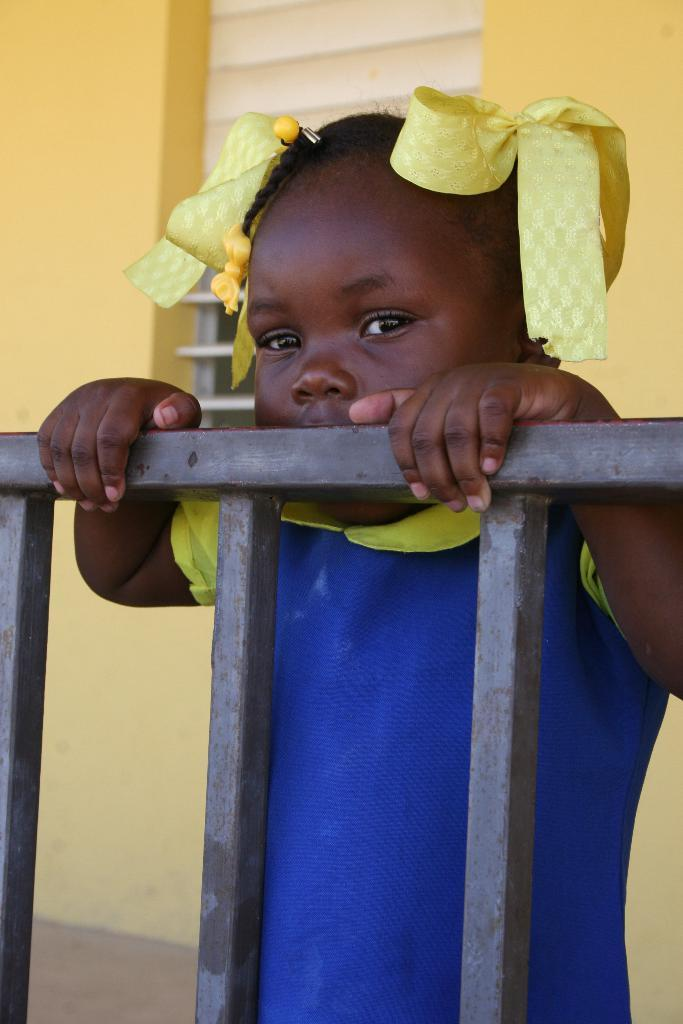What is the main subject of the image? There is a girl standing in the image. What objects can be seen near the girl? There are rods visible in the image. What can be seen in the background of the image? There is a wall and a window in the background of the image. What type of flame can be seen coming from the kite in the image? There is no kite present in the image, and therefore no flame can be seen coming from it. 